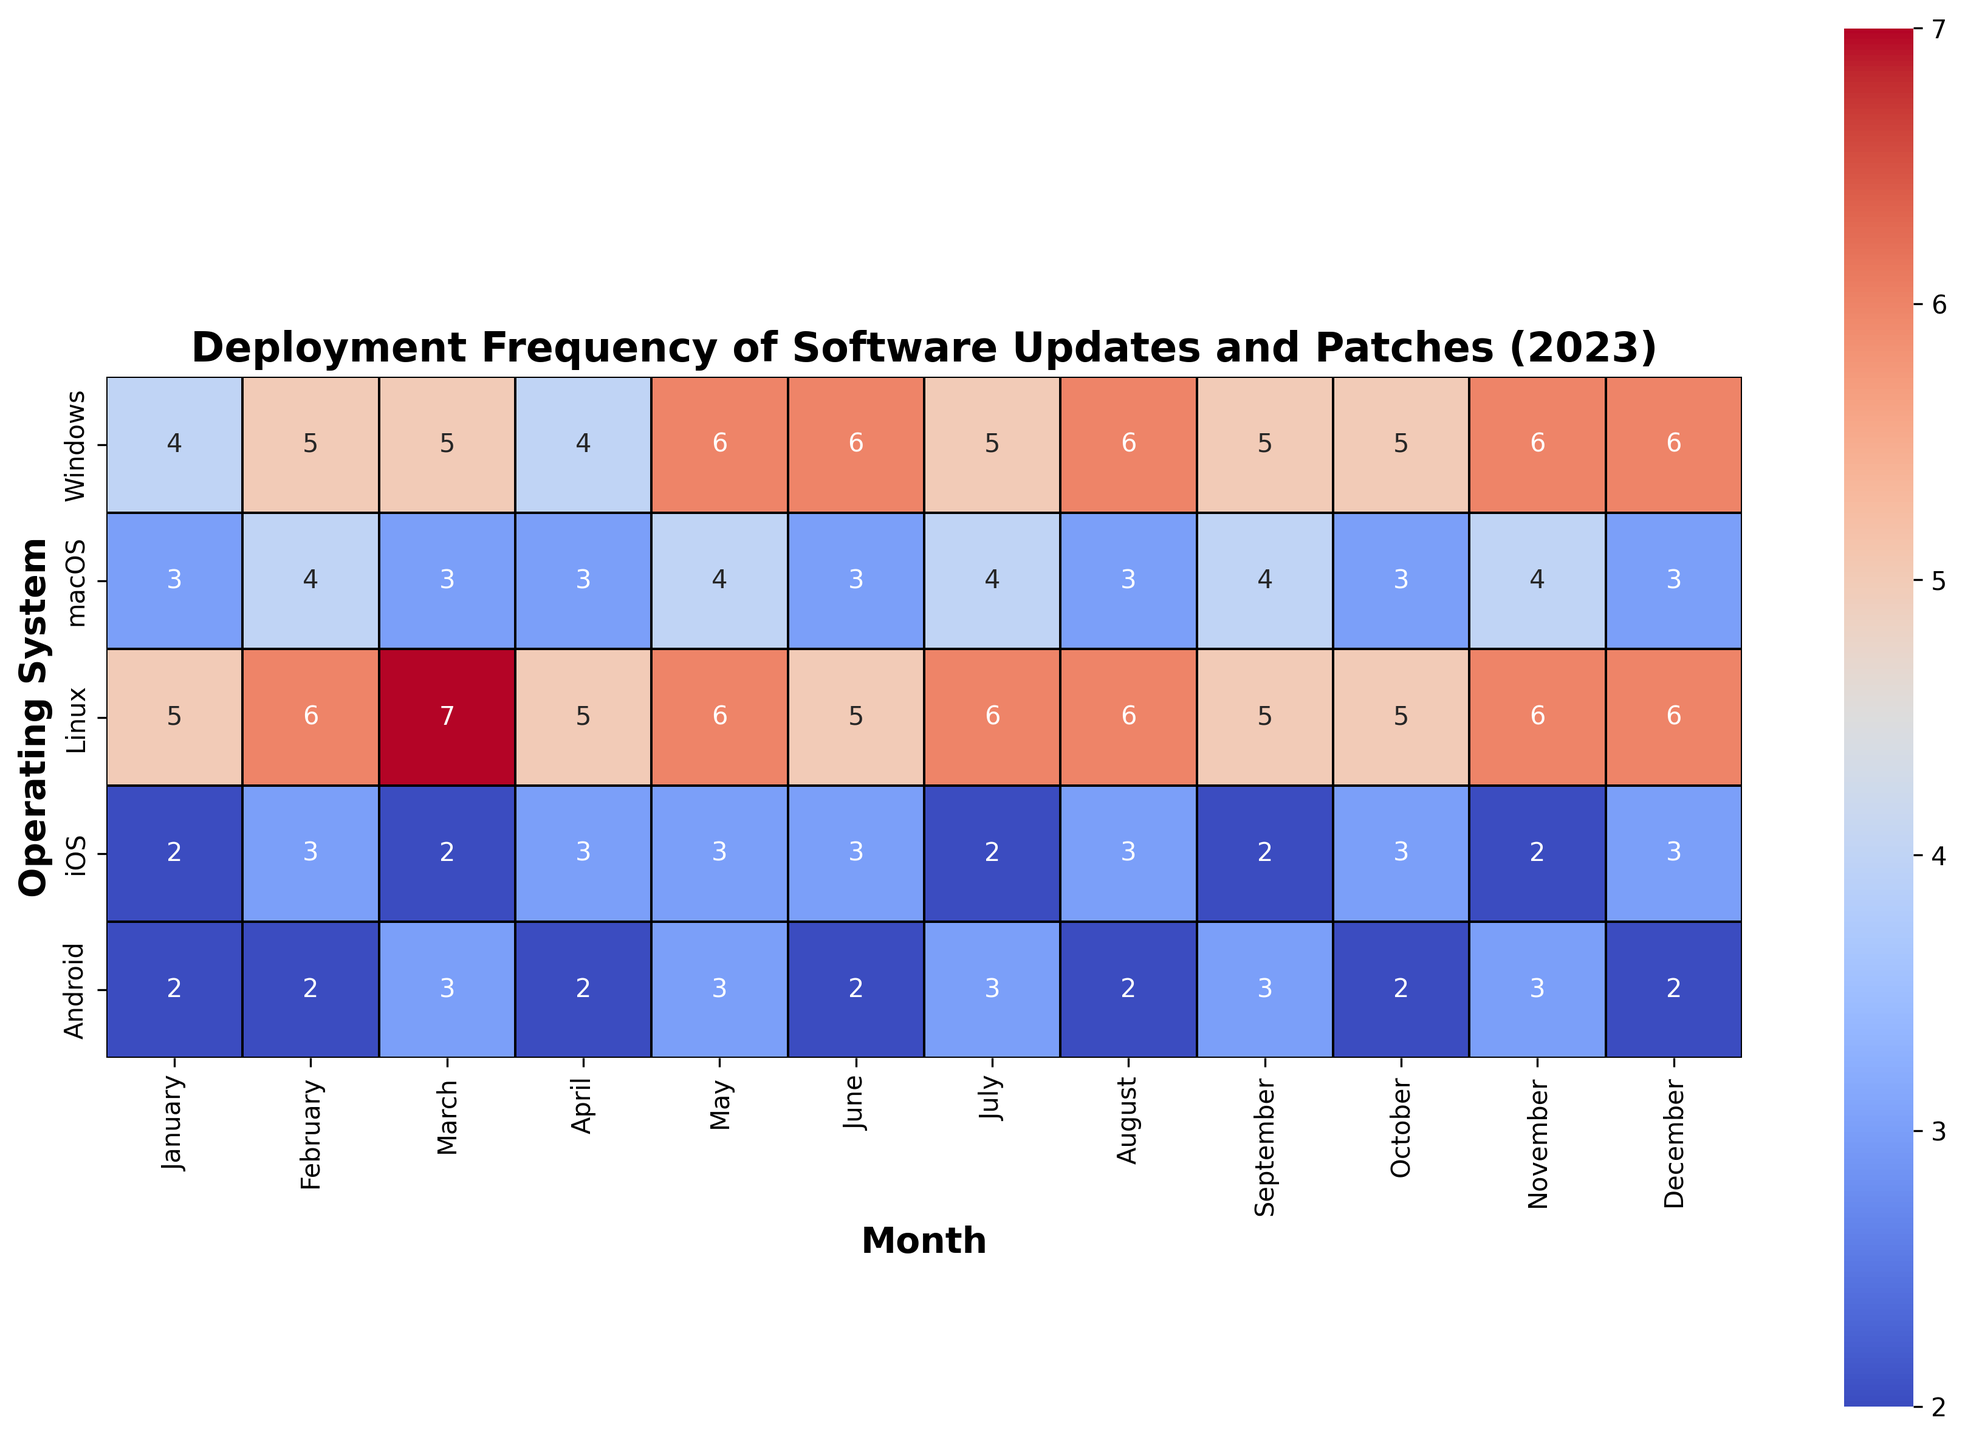Which month had the highest deployment frequency for Windows? By looking at the heatmap in the row for Windows, the highest numbers (6) appear in May, June, November, and December. Therefore, May, June, November, and December had the highest deployment frequency for Windows.
Answer: May, June, November, December Which operating system had the most frequent updates in March? By examining the March column in the heatmap, the highest number (7) is seen for Linux, indicating that Linux had the most frequent updates in March.
Answer: Linux What is the difference in deployment frequency between Windows and macOS in June? For June, the heatmap shows '6' for Windows and '3' for macOS. The difference is 6 - 3 = 3.
Answer: 3 What is the average deployment frequency for Android across the year? The deployment frequencies for Android are: 2, 2, 3, 2, 3, 2, 3, 2, 3, 2, 3, 2. Summing these up gives 31. There are 12 months, so the average is 31 / 12 ≈ 2.58.
Answer: 2.58 How many times did Linux have an update frequency greater than 5? In the heatmap for Linux, the months where the value is greater than 5 are: March (7), June (6), August (6), November (6), and December (6). So, Linux had an update frequency greater than 5 in 5 months.
Answer: 5 Which operating system showed the least variation in deployment frequency throughout the year? The least variation can be visually identified by looking at the color consistency along a row. macOS and Android show the least variation. Since the numbers for macOS are either 3 or 4 and for Android they are mostly 2 or 3, both have low variation.
Answer: macOS, Android Which month had the overall minimum deployment frequency across all operating systems? The overall minimum deployment frequency is 2. Checking the heatmap, the value '2' appears for iOS and Android in several months: January, March, May, July, September, November.
Answer: January, March, May, July, September, November In which quarter (Jan-Mar, Apr-Jun, Jul-Sep, Oct-Dec) did Windows have the most updates combined? Summing the deployment frequencies for each quarter: Q1 (14), Q2 (16), Q3 (16), Q4 (17). Windows had the most updates combined in Q4.
Answer: Q4 